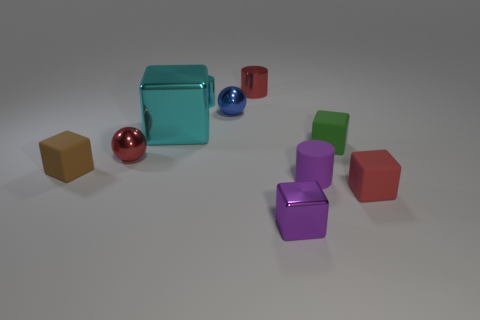How many blocks are red objects or blue shiny objects?
Your answer should be compact. 1. How many metal objects are both behind the blue metallic sphere and left of the blue shiny sphere?
Your answer should be very brief. 1. Are there the same number of cyan cylinders to the left of the big metallic cube and small cylinders left of the small brown object?
Your response must be concise. Yes. There is a large cyan object that is to the right of the red sphere; does it have the same shape as the tiny brown matte thing?
Make the answer very short. Yes. The tiny shiny thing that is in front of the small rubber object that is left of the thing in front of the red block is what shape?
Provide a short and direct response. Cube. The small object that is the same color as the big block is what shape?
Your answer should be compact. Cylinder. What is the tiny block that is behind the purple rubber cylinder and right of the brown matte object made of?
Your response must be concise. Rubber. Is the number of metal objects less than the number of big gray matte balls?
Give a very brief answer. No. There is a small green object; is it the same shape as the cyan metallic object in front of the blue ball?
Make the answer very short. Yes. Is the size of the metallic cylinder left of the red cylinder the same as the cyan cube?
Make the answer very short. No. 